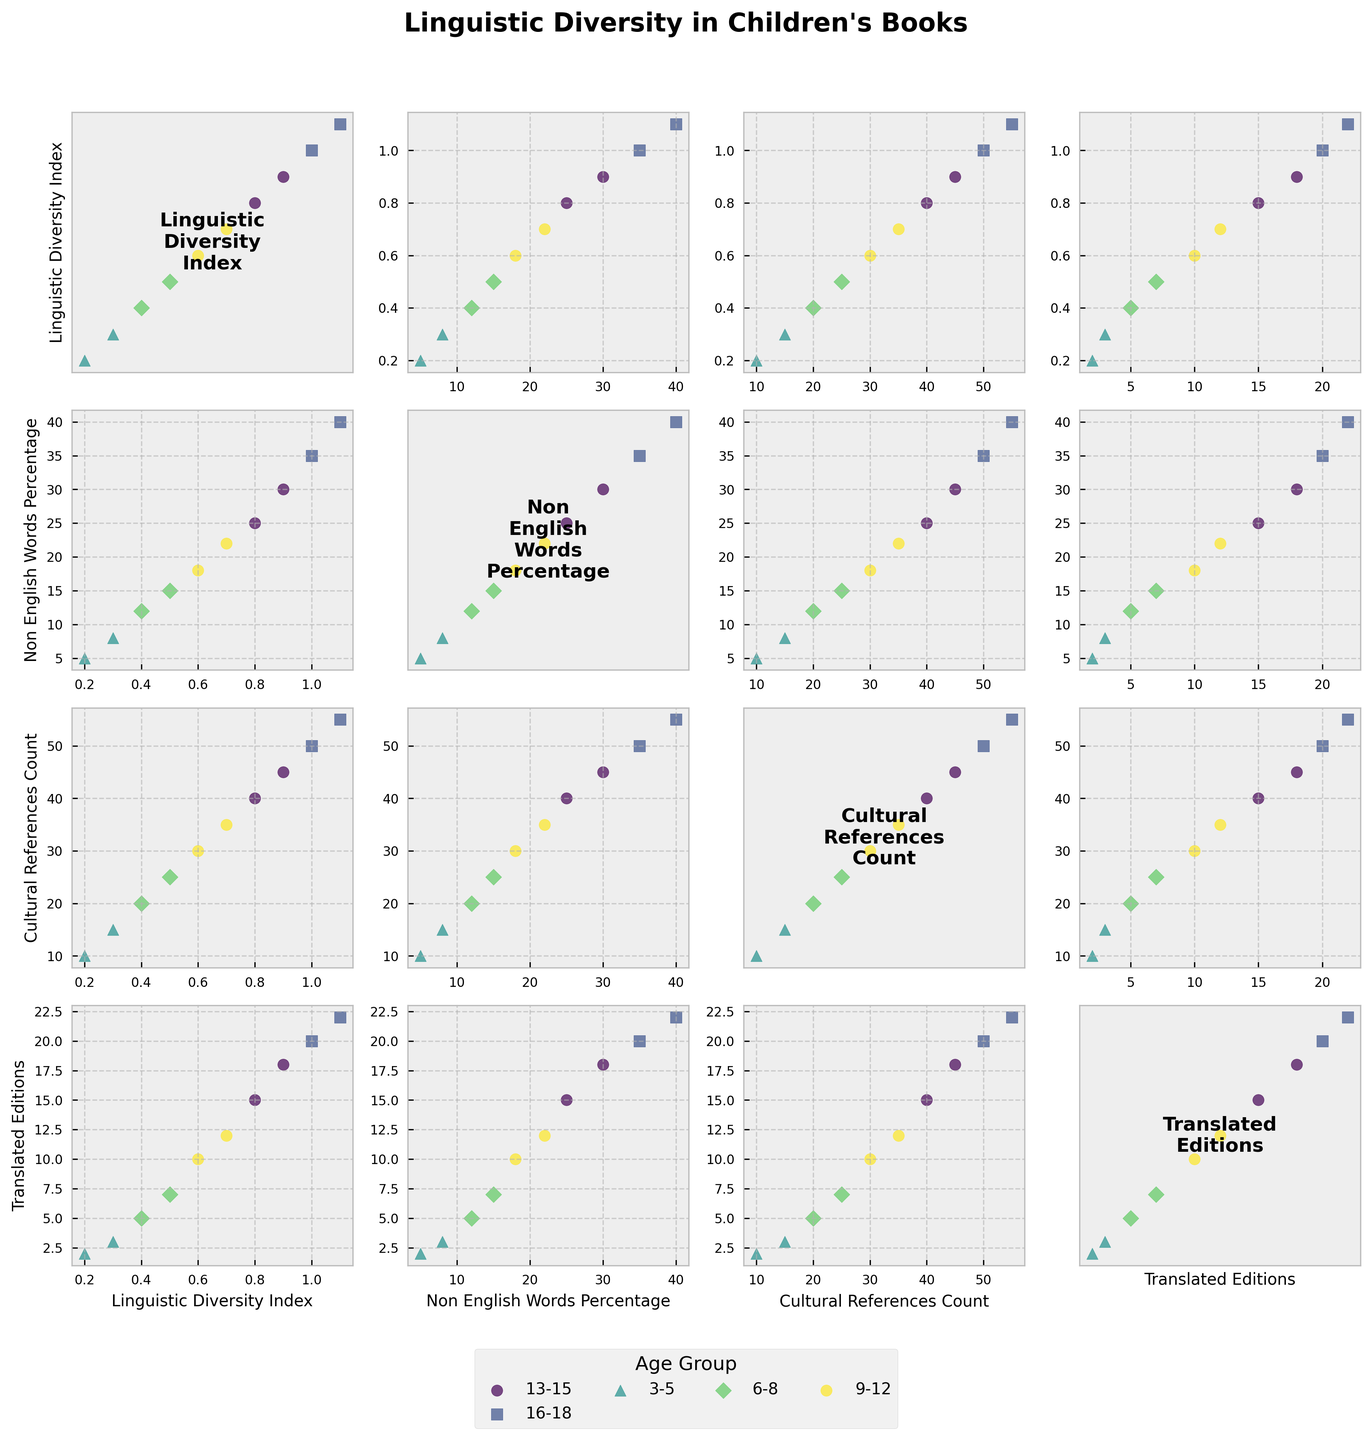What is the title of the figure? The title appears at the top of the figure, which is "Linguistic Diversity in Children's Books".
Answer: Linguistic Diversity in Children's Books What is the maximum value of the Linguistic Diversity Index for the 3-5 age group? In the scatterplot matrix, find the row and column corresponding to the "Linguistic Diversity Index" and look for the maximum value within the 3-5 age group markers, which are likely the first few markers.
Answer: 0.3 How does the percentage of non-English words in books change as the reading level increases? Check the "Non English Words Percentage" column in each scatterplot and observe the increasing trend as reading levels go from Early Reader to Young Adult.
Answer: Increases Which age group has the highest number of cultural references in their books? Check all the scatterplots with "Cultural References Count" as one of the axes, and identify the highest data point, given that the highest reading level (16-18) usually correlates with a higher count.
Answer: 16-18 Between the age groups 9-12 and 13-15, which has a higher average percentage of non-English words? Find the scatterplots involving the "Non English Words Percentage". Calculate the average percentages for both age groups by adding the percentages and dividing by the number of data points for each age group. The 13-15 age group will have a higher average, given the data trends.
Answer: 13-15 Is there a correlation between the number of translated editions and the Linguistic Diversity Index? Look at the scatterplot where "Translated Editions" and "Linguistic Diversity Index" are plotted against each other, and observe if there's a positive trend, meaning as the index increases, so do the editions.
Answer: Yes, positive correlation Which reading level within the 6-8 age group has the most translated editions? Refer to the scatterplots involving "Translated Editions" and pinpoint the markers corresponding to the 6-8 age group. The Advanced reading level within this group usually has the highest readings.
Answer: Advanced Compare the number of cultural references in books for the 3-5 age group and the 16-18 age group. Which group has more? Identify the scatterplots with "Cultural References Count" and compare values for the 3-5 with those of 16-18. The data shows that the 16-18 age group consistently has higher values.
Answer: 16-18 How do the linguistic diversity and cultural references counts correlate for the 9-12 age group? Look at the scatterplot matrix between "Linguistic Diversity Index" and "Cultural References Count". Check the markers for the 9-12 age group and observe if there is a positive or any correlation.
Answer: Positive correlation Which metric has the most pronounced increase across all age groups: Linguistic Diversity Index, Non-English Words Percentage, Cultural References Count, or Translated Editions? Compare the overall trends across all scatterplots for each metric and see which increases most noticeably from younger to older age groups. The "Translated Editions" increases the most markedly.
Answer: Translated Editions 